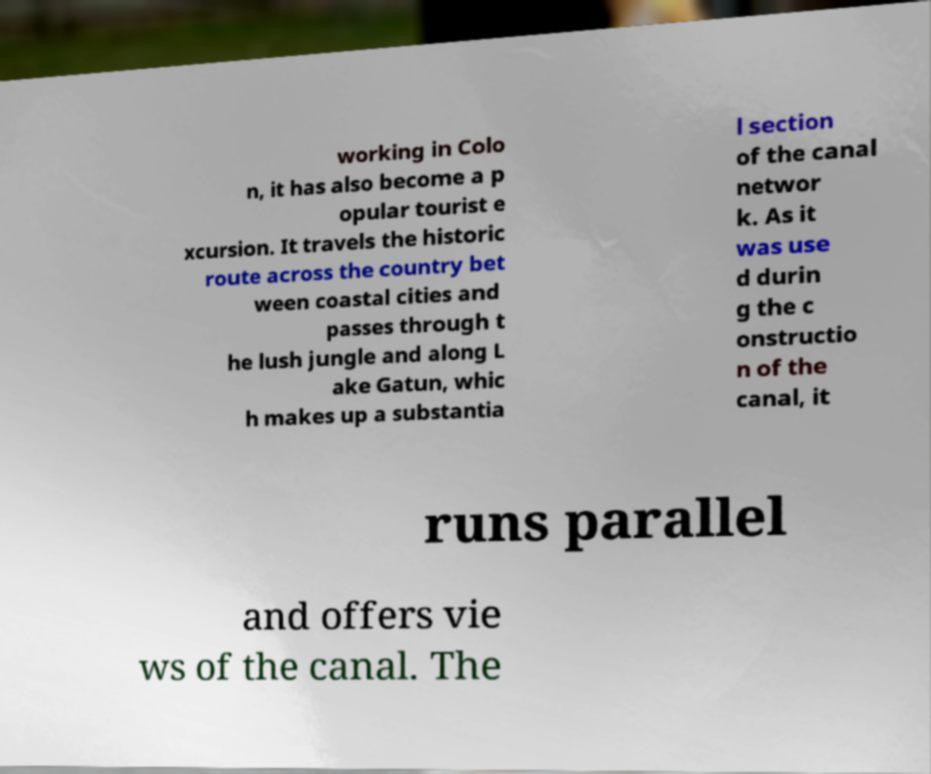For documentation purposes, I need the text within this image transcribed. Could you provide that? working in Colo n, it has also become a p opular tourist e xcursion. It travels the historic route across the country bet ween coastal cities and passes through t he lush jungle and along L ake Gatun, whic h makes up a substantia l section of the canal networ k. As it was use d durin g the c onstructio n of the canal, it runs parallel and offers vie ws of the canal. The 